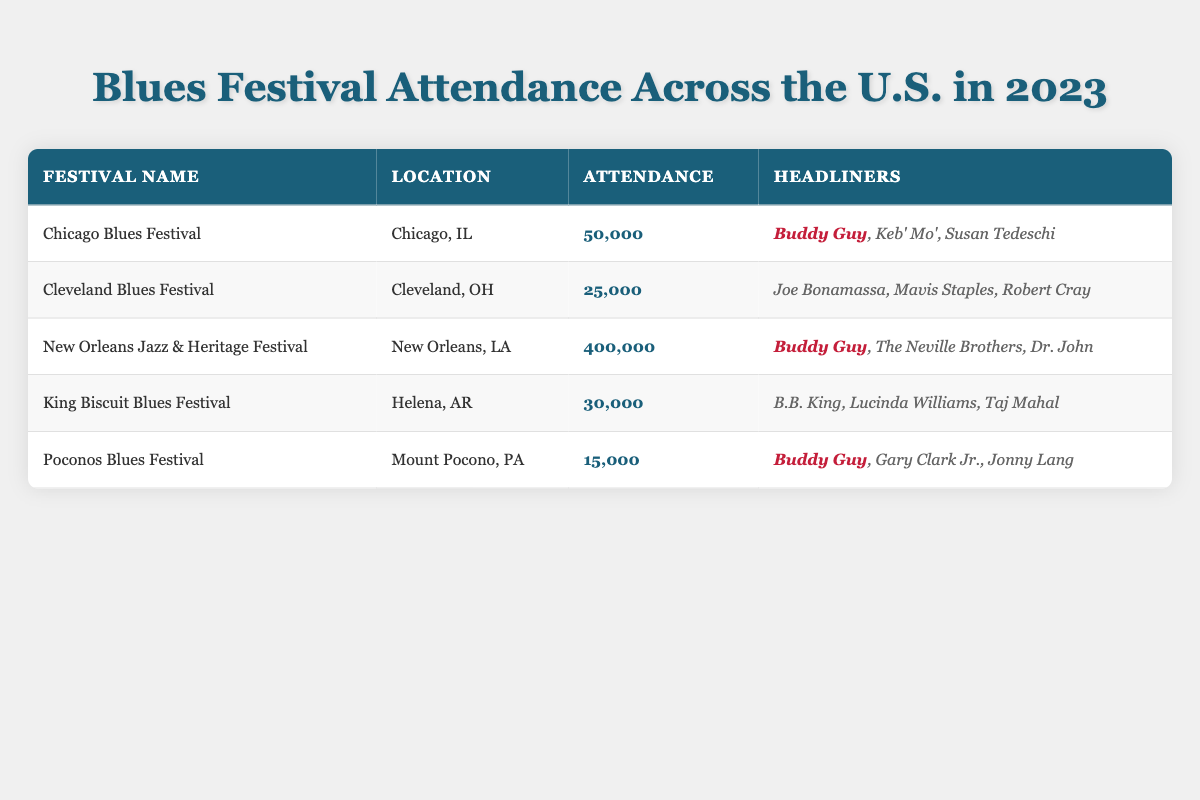What is the total attendance across all festivals? To find the total attendance, we sum the attendance figures of all five festivals: 50000 (Chicago) + 25000 (Cleveland) + 400000 (New Orleans) + 30000 (Helena) + 15000 (Mount Pocono) = 525000.
Answer: 525000 Which festival had the highest attendance? The festival with the highest attendance is the New Orleans Jazz & Heritage Festival, with an attendance of 400000. This can be directly seen in the table by comparing the attendance numbers.
Answer: New Orleans Jazz & Heritage Festival How many festivals had an attendance of more than 30000? The festivals with attendance greater than 30000 are: New Orleans Jazz & Heritage Festival (400000), Chicago Blues Festival (50000), and King Biscuit Blues Festival (30000). The count is 3, but inclusion of the King Biscuit implies a strict greater than 30000, so it's 2.
Answer: 2 Is Buddy Guy a headliner in all listed festivals? Buddy Guy is listed as a headliner in three festivals: Chicago Blues Festival, New Orleans Jazz & Heritage Festival, and Poconos Blues Festival. Since he is not a headliner in the Cleveland and King Biscuit Blues Festivals, the answer is no.
Answer: No What is the average attendance of the festivals? To calculate the average attendance, we first sum up the attendance (as done previously, that gives 525000) and then divide that by the number of festivals (5). Thus, average attendance = 525000 / 5 = 105000.
Answer: 105000 Which location has the lowest festival attendance? The location with the lowest attendance is Mount Pocono, PA, with the Poconos Blues Festival having an attendance of 15000, which is the smallest number in the attendance column.
Answer: Mount Pocono, PA How many headliners are listed for the Chicago Blues Festival? The Chicago Blues Festival has three headliners: Buddy Guy, Keb' Mo', and Susan Tedeschi. This can be confirmed by counting the names listed in the headliners column for that festival.
Answer: 3 What is the difference in attendance between the New Orleans Jazz & Heritage Festival and the Poconos Blues Festival? We calculate the difference by subtracting the Poconos attendance (15000) from the New Orleans attendance (400000): 400000 - 15000 = 385000.
Answer: 385000 How many festivals feature B.B. King as a headliner? Only one festival, the King Biscuit Blues Festival in Helena, AR, features B.B. King as a headliner. Therefore, the answer is one.
Answer: 1 